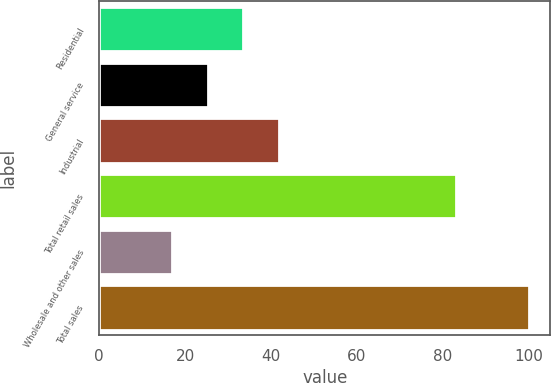<chart> <loc_0><loc_0><loc_500><loc_500><bar_chart><fcel>Residential<fcel>General service<fcel>Industrial<fcel>Total retail sales<fcel>Wholesale and other sales<fcel>Total sales<nl><fcel>33.6<fcel>25.3<fcel>41.9<fcel>83<fcel>17<fcel>100<nl></chart> 